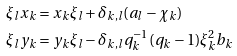Convert formula to latex. <formula><loc_0><loc_0><loc_500><loc_500>\xi _ { l } x _ { k } & = x _ { k } \xi _ { l } + \delta _ { k , l } ( a _ { l } - \chi _ { k } ) \\ \xi _ { l } y _ { k } & = y _ { k } \xi _ { l } - \delta _ { k , l } q _ { k } ^ { - 1 } ( q _ { k } - 1 ) \xi _ { k } ^ { 2 } b _ { k }</formula> 